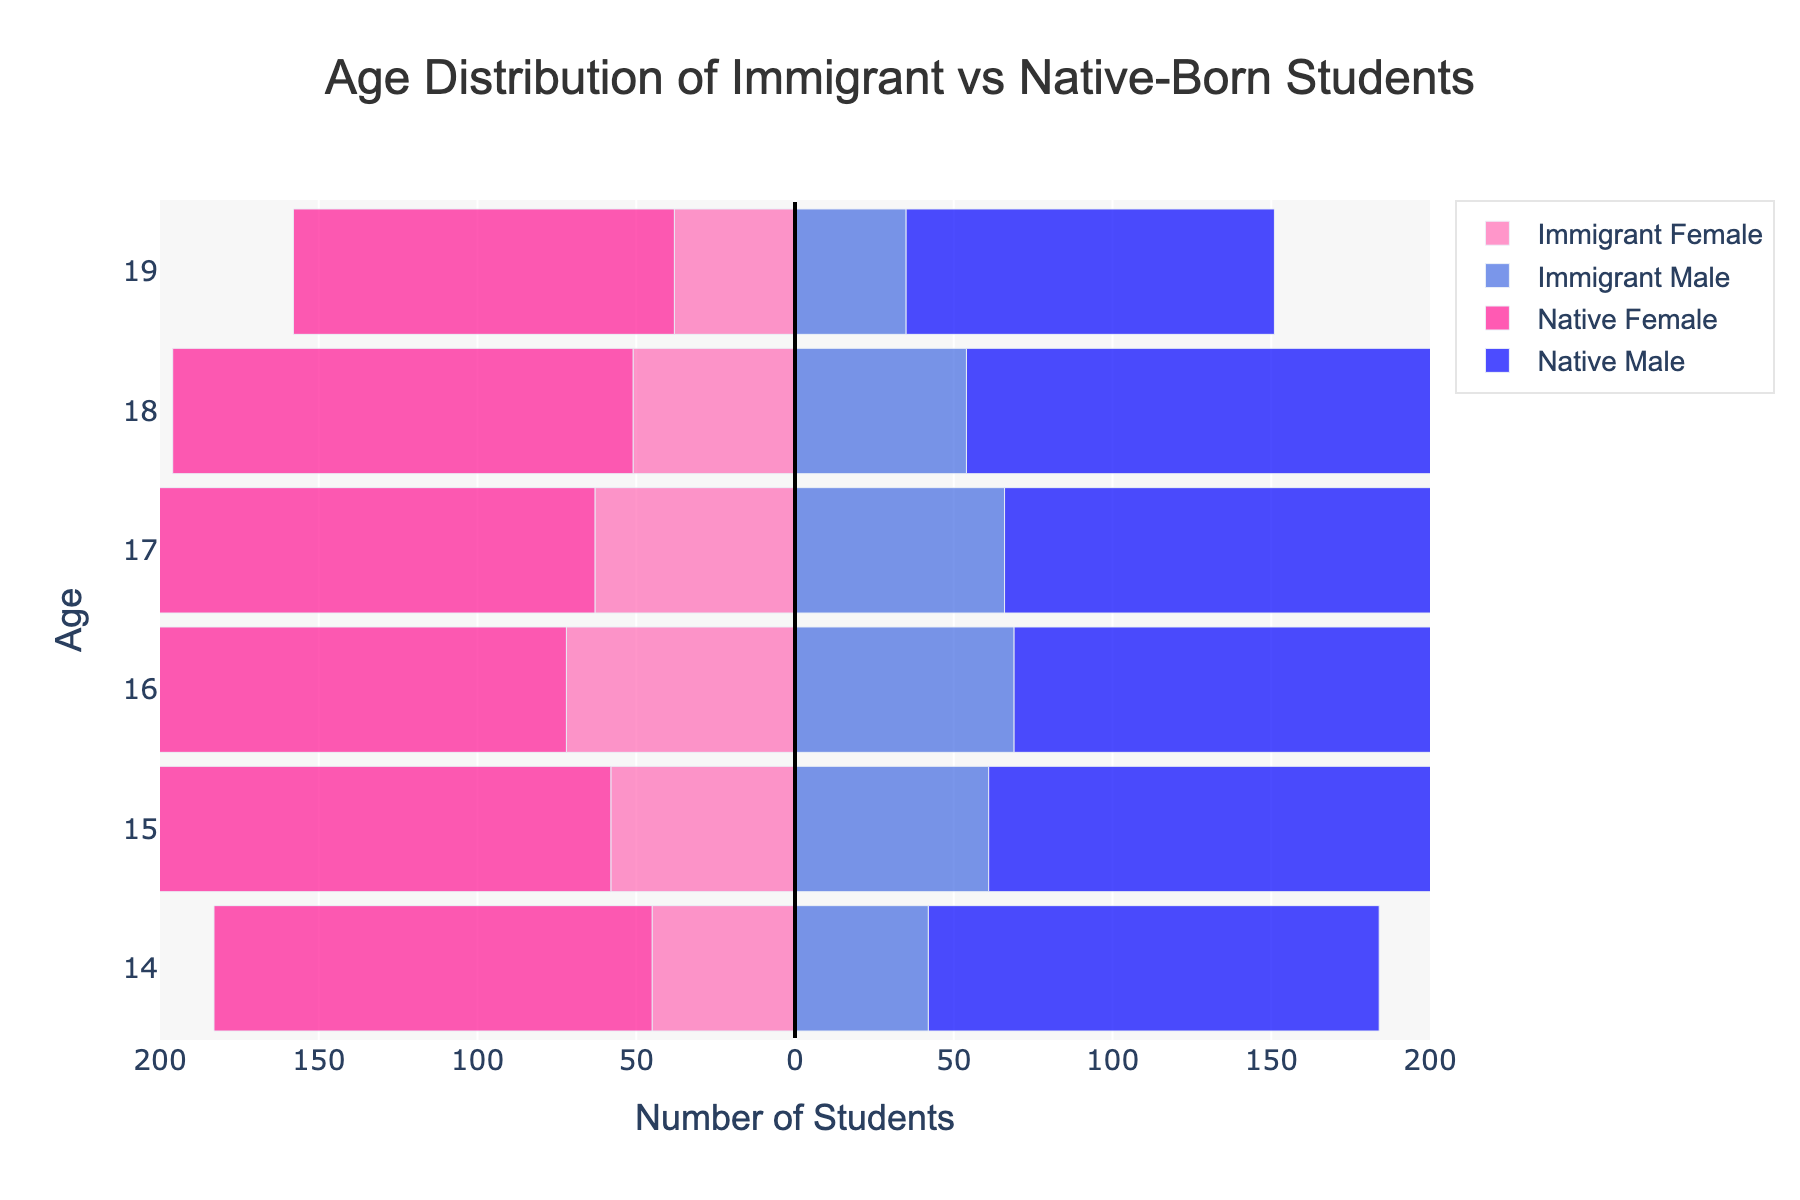What is the title of the figure? The title is displayed prominently at the top of the figure in large font size. It states the purpose of the figure.
Answer: Age Distribution of Immigrant vs Native-Born Students How many age groups are shown in the figure? The age groups are represented by the bars along the y-axis. Each bar corresponds to an age from 14 to 19, so we count these groups.
Answer: 6 Which color represents Immigrant Female students? We look at the color legend at the top or within the figure. Immigrant Female students are marked by a pinkish color.
Answer: Pinkish (#FF69B4) At age 16, which group has the highest number of students? We compare the lengths of the bars at age 16 on both sides of the vertical line, focusing on both immigrant and native groups. The Native Male bar is the longest.
Answer: Native Male What is the total number of Immigrant Male students between ages 14 and 18? We sum up the values of the Immigrant Male group from ages 14 to 18: 42 + 61 + 69 + 66 + 54. Adding these numbers gives us 292.
Answer: 292 What is the average number of Native Female students from ages 14 to 19? We sum up the values of Native Female students for each age and divide by the number of age groups (6): (138 + 152 + 165 + 159 + 145 + 120) / 6. This calculation equals 879 / 6 = 146.5.
Answer: 146.5 Which age group has the lowest number of Immigrant Female students? We look at the negative bars (left-hand side) for Immigrant Female students and identify the shortest one, which corresponds to age 19.
Answer: 19 For age 17, how many more Native Female students are there compared to Immigrant Female students? We look at the lengths of bars for Native Female at age 17 and Immigrant Female at age 17. Native Female: 159, Immigrant Female: 63. Difference is 159 - 63 = 96.
Answer: 96 At what age do Native Males and Native Females have the closest number of students? We compare the lengths of bars for both groups across different ages and find the smallest difference. At age 15, Native Males (149) and Native Females (152) differ by only 3.
Answer: 15 Which group has the largest gender disparity for a single age group? We calculate the differences between the male and female bars for each group across all ages. The largest disparity occurs for Native students at age 19 with a difference: Native Female (120) - Native Male (116) = 4, and it's the largest among others.
Answer: Native (Age 19) 